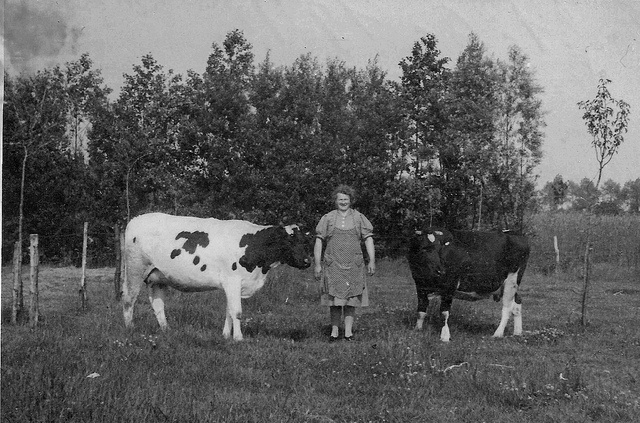Describe the objects in this image and their specific colors. I can see cow in gray, lightgray, darkgray, and black tones, cow in gray, black, darkgray, and lightgray tones, and people in gray, black, and lightgray tones in this image. 